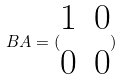<formula> <loc_0><loc_0><loc_500><loc_500>B A = ( \begin{matrix} 1 & 0 \\ 0 & 0 \end{matrix} )</formula> 